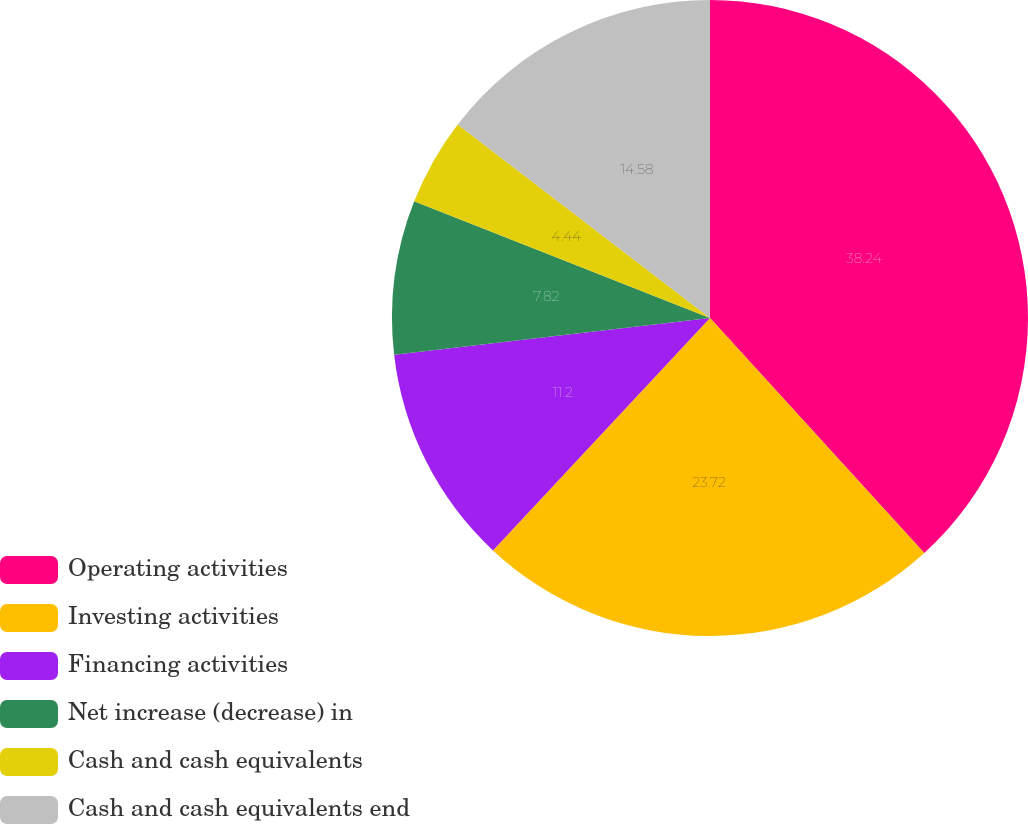Convert chart. <chart><loc_0><loc_0><loc_500><loc_500><pie_chart><fcel>Operating activities<fcel>Investing activities<fcel>Financing activities<fcel>Net increase (decrease) in<fcel>Cash and cash equivalents<fcel>Cash and cash equivalents end<nl><fcel>38.23%<fcel>23.72%<fcel>11.2%<fcel>7.82%<fcel>4.44%<fcel>14.58%<nl></chart> 